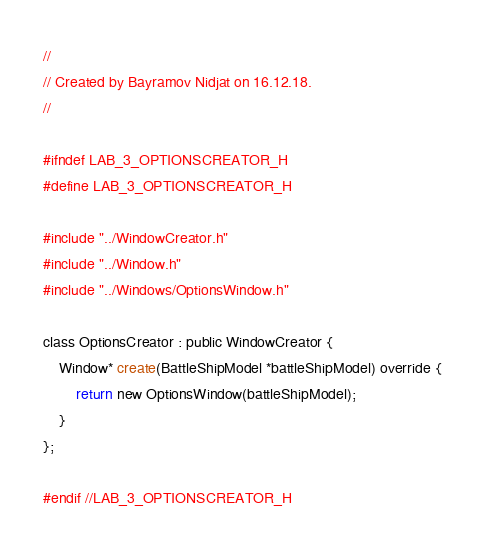Convert code to text. <code><loc_0><loc_0><loc_500><loc_500><_C_>//
// Created by Bayramov Nidjat on 16.12.18.
//

#ifndef LAB_3_OPTIONSCREATOR_H
#define LAB_3_OPTIONSCREATOR_H

#include "../WindowCreator.h"
#include "../Window.h"
#include "../Windows/OptionsWindow.h"

class OptionsCreator : public WindowCreator {
    Window* create(BattleShipModel *battleShipModel) override {
        return new OptionsWindow(battleShipModel);
    }
};

#endif //LAB_3_OPTIONSCREATOR_H
</code> 